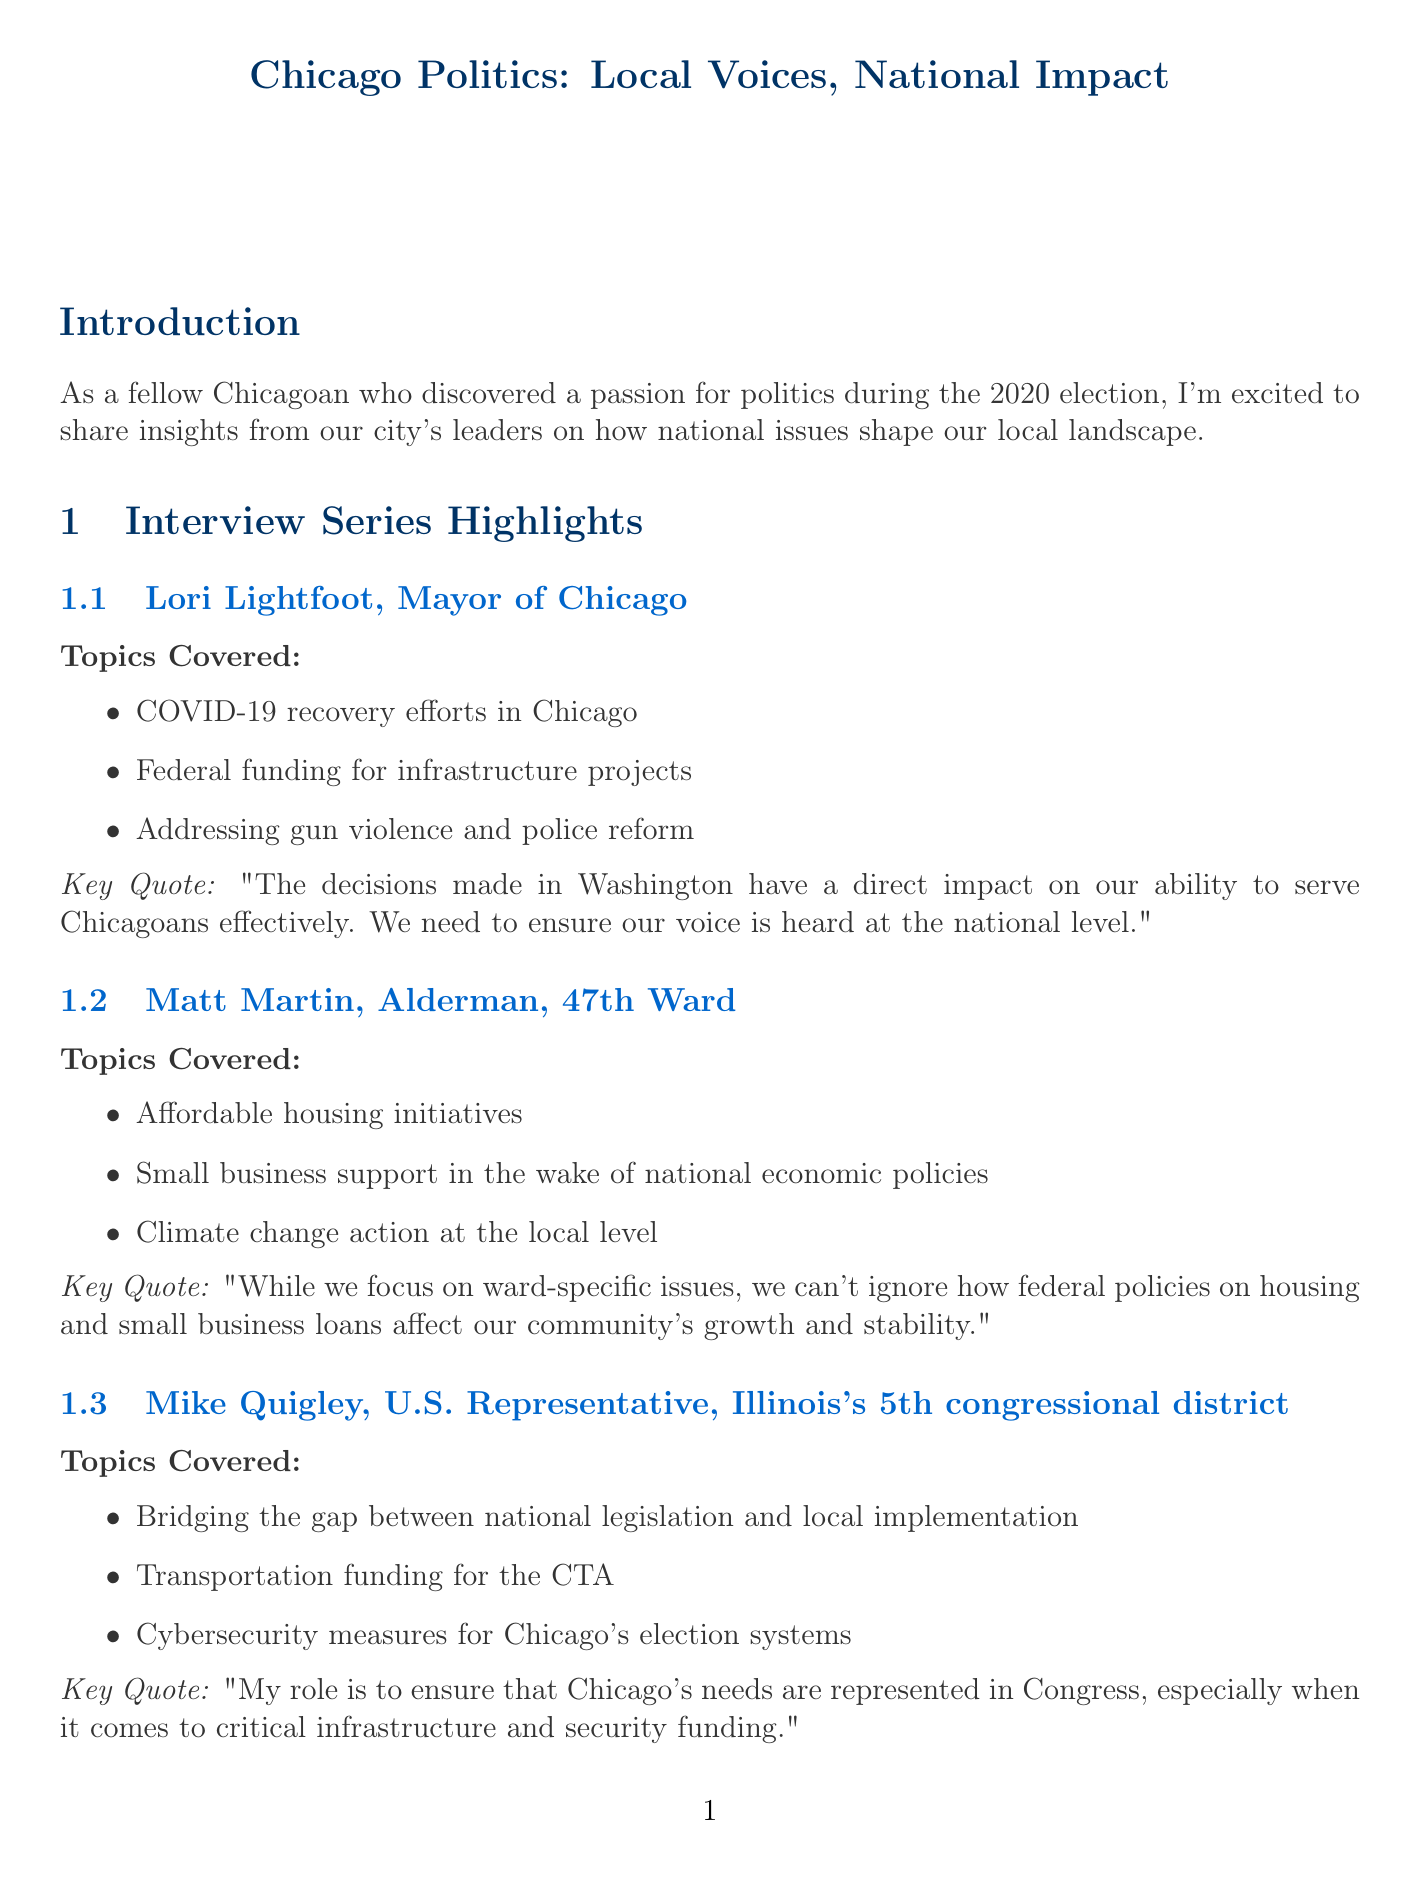What is the title of the newsletter? The title of the newsletter is stated at the beginning of the document.
Answer: Chicago Politics: Local Voices, National Impact Who is the Alderman for the 47th Ward? The document mentions the name of the Alderman in the interview series section.
Answer: Matt Martin What date is the Town Hall event scheduled? The date for the Town Hall event is explicitly mentioned in the events section.
Answer: July 15, 2023 What key topic does Lori Lightfoot discuss regarding national impact? The summary of topics covered by each politician includes key national impact issues.
Answer: Federal funding for infrastructure projects What is the location of the Civic Engagement Workshop? The document provides details about the location for each upcoming event.
Answer: UIC Forum How many volunteer opportunities are listed? The number of items in the volunteer opportunities section determines the answer.
Answer: Three What is a key quote from Mike Quigley? The document includes key quotes for each politician in their respective sections.
Answer: "My role is to ensure that Chicago's needs are represented in Congress, especially when it comes to critical infrastructure and security funding." What is the main focus of the Civic Engagement Workshop? The description in the events section summarizes the focus of the workshop.
Answer: Communicate with your representatives What are participants encouraged to do at the upcoming events? The events section describes the main activities participants are urged to engage in.
Answer: Join discussions and learn to communicate effectively 